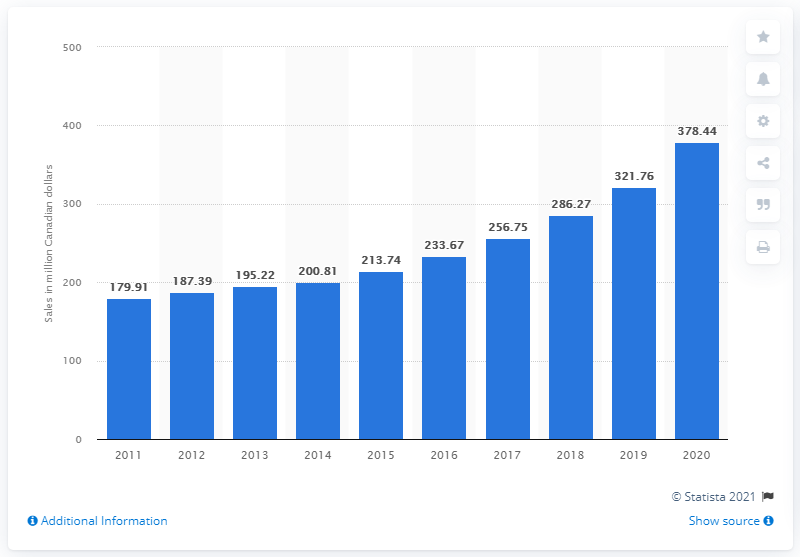Mention a couple of crucial points in this snapshot. The sales value of gin in Canada during the fiscal year ending March 31, 2020, was CAD 378.44. 